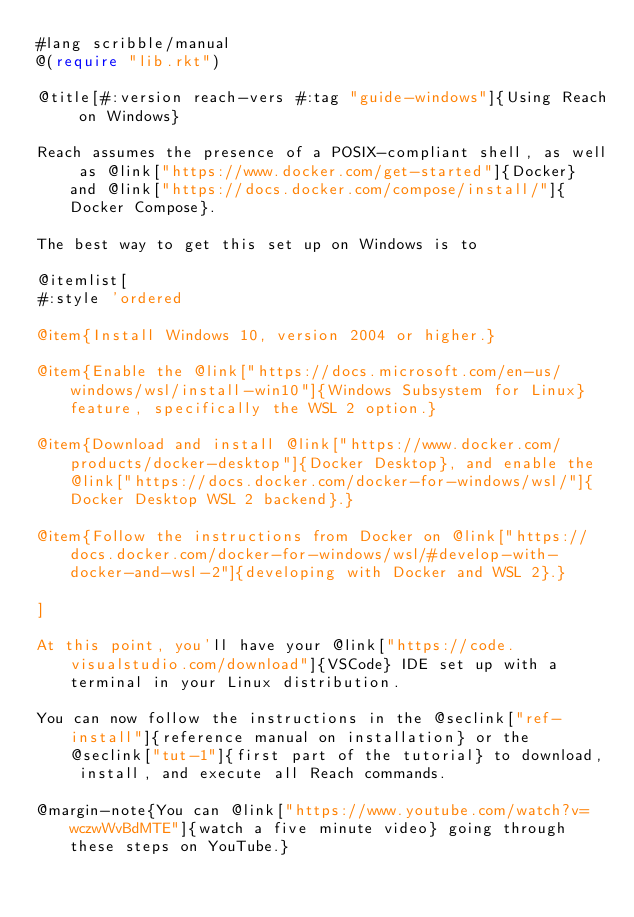<code> <loc_0><loc_0><loc_500><loc_500><_Racket_>#lang scribble/manual
@(require "lib.rkt")

@title[#:version reach-vers #:tag "guide-windows"]{Using Reach on Windows}

Reach assumes the presence of a POSIX-compliant shell, as well as @link["https://www.docker.com/get-started"]{Docker} and @link["https://docs.docker.com/compose/install/"]{Docker Compose}.

The best way to get this set up on Windows is to

@itemlist[
#:style 'ordered

@item{Install Windows 10, version 2004 or higher.}

@item{Enable the @link["https://docs.microsoft.com/en-us/windows/wsl/install-win10"]{Windows Subsystem for Linux} feature, specifically the WSL 2 option.}

@item{Download and install @link["https://www.docker.com/products/docker-desktop"]{Docker Desktop}, and enable the @link["https://docs.docker.com/docker-for-windows/wsl/"]{Docker Desktop WSL 2 backend}.}

@item{Follow the instructions from Docker on @link["https://docs.docker.com/docker-for-windows/wsl/#develop-with-docker-and-wsl-2"]{developing with Docker and WSL 2}.}

]

At this point, you'll have your @link["https://code.visualstudio.com/download"]{VSCode} IDE set up with a terminal in your Linux distribution.

You can now follow the instructions in the @seclink["ref-install"]{reference manual on installation} or the @seclink["tut-1"]{first part of the tutorial} to download, install, and execute all Reach commands.

@margin-note{You can @link["https://www.youtube.com/watch?v=wczwWvBdMTE"]{watch a five minute video} going through these steps on YouTube.}
</code> 